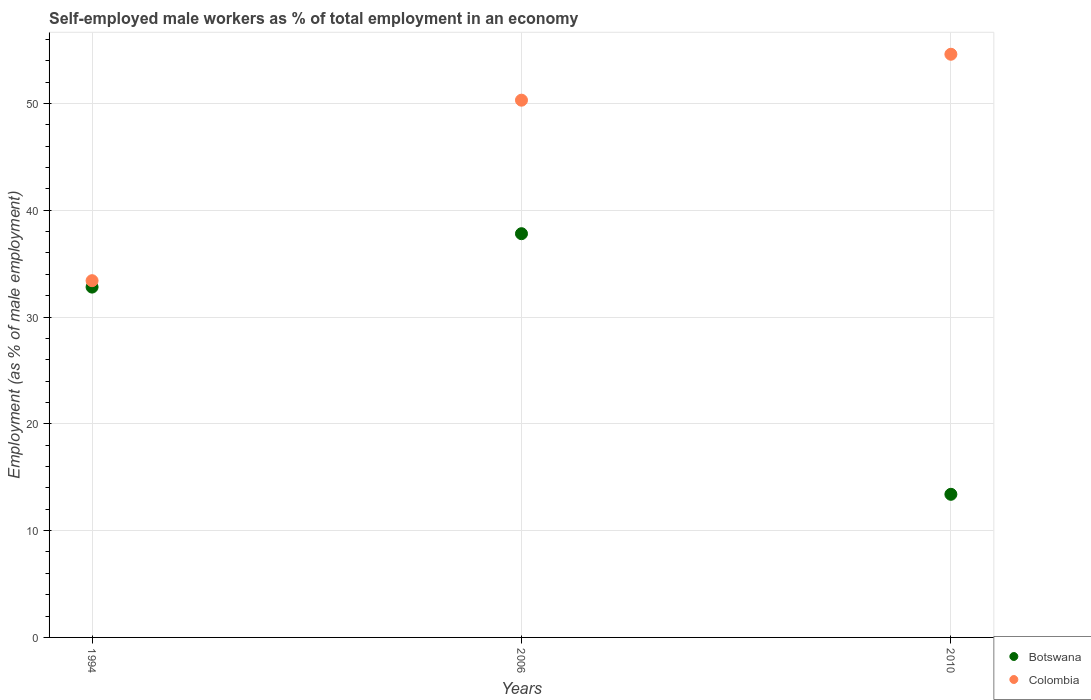How many different coloured dotlines are there?
Your answer should be compact. 2. Is the number of dotlines equal to the number of legend labels?
Give a very brief answer. Yes. What is the percentage of self-employed male workers in Colombia in 2006?
Ensure brevity in your answer.  50.3. Across all years, what is the maximum percentage of self-employed male workers in Botswana?
Provide a short and direct response. 37.8. Across all years, what is the minimum percentage of self-employed male workers in Colombia?
Provide a succinct answer. 33.4. In which year was the percentage of self-employed male workers in Botswana minimum?
Your response must be concise. 2010. What is the total percentage of self-employed male workers in Botswana in the graph?
Your response must be concise. 84. What is the difference between the percentage of self-employed male workers in Botswana in 1994 and that in 2006?
Ensure brevity in your answer.  -5. What is the difference between the percentage of self-employed male workers in Colombia in 2006 and the percentage of self-employed male workers in Botswana in 1994?
Keep it short and to the point. 17.5. What is the average percentage of self-employed male workers in Colombia per year?
Give a very brief answer. 46.1. In the year 1994, what is the difference between the percentage of self-employed male workers in Colombia and percentage of self-employed male workers in Botswana?
Your answer should be very brief. 0.6. In how many years, is the percentage of self-employed male workers in Colombia greater than 10 %?
Make the answer very short. 3. What is the ratio of the percentage of self-employed male workers in Botswana in 1994 to that in 2010?
Your answer should be very brief. 2.45. Is the difference between the percentage of self-employed male workers in Colombia in 2006 and 2010 greater than the difference between the percentage of self-employed male workers in Botswana in 2006 and 2010?
Your response must be concise. No. What is the difference between the highest and the second highest percentage of self-employed male workers in Colombia?
Offer a terse response. 4.3. What is the difference between the highest and the lowest percentage of self-employed male workers in Colombia?
Provide a short and direct response. 21.2. In how many years, is the percentage of self-employed male workers in Botswana greater than the average percentage of self-employed male workers in Botswana taken over all years?
Keep it short and to the point. 2. How many dotlines are there?
Your response must be concise. 2. How many years are there in the graph?
Give a very brief answer. 3. Are the values on the major ticks of Y-axis written in scientific E-notation?
Keep it short and to the point. No. Does the graph contain any zero values?
Provide a short and direct response. No. Does the graph contain grids?
Provide a short and direct response. Yes. Where does the legend appear in the graph?
Provide a short and direct response. Bottom right. How many legend labels are there?
Give a very brief answer. 2. How are the legend labels stacked?
Provide a short and direct response. Vertical. What is the title of the graph?
Offer a very short reply. Self-employed male workers as % of total employment in an economy. Does "Estonia" appear as one of the legend labels in the graph?
Your answer should be very brief. No. What is the label or title of the Y-axis?
Your answer should be compact. Employment (as % of male employment). What is the Employment (as % of male employment) in Botswana in 1994?
Ensure brevity in your answer.  32.8. What is the Employment (as % of male employment) in Colombia in 1994?
Your answer should be very brief. 33.4. What is the Employment (as % of male employment) of Botswana in 2006?
Give a very brief answer. 37.8. What is the Employment (as % of male employment) of Colombia in 2006?
Provide a succinct answer. 50.3. What is the Employment (as % of male employment) in Botswana in 2010?
Your response must be concise. 13.4. What is the Employment (as % of male employment) of Colombia in 2010?
Keep it short and to the point. 54.6. Across all years, what is the maximum Employment (as % of male employment) in Botswana?
Give a very brief answer. 37.8. Across all years, what is the maximum Employment (as % of male employment) of Colombia?
Your answer should be compact. 54.6. Across all years, what is the minimum Employment (as % of male employment) of Botswana?
Your response must be concise. 13.4. Across all years, what is the minimum Employment (as % of male employment) in Colombia?
Provide a short and direct response. 33.4. What is the total Employment (as % of male employment) in Colombia in the graph?
Keep it short and to the point. 138.3. What is the difference between the Employment (as % of male employment) of Colombia in 1994 and that in 2006?
Your answer should be very brief. -16.9. What is the difference between the Employment (as % of male employment) of Colombia in 1994 and that in 2010?
Your answer should be compact. -21.2. What is the difference between the Employment (as % of male employment) in Botswana in 2006 and that in 2010?
Give a very brief answer. 24.4. What is the difference between the Employment (as % of male employment) of Botswana in 1994 and the Employment (as % of male employment) of Colombia in 2006?
Ensure brevity in your answer.  -17.5. What is the difference between the Employment (as % of male employment) of Botswana in 1994 and the Employment (as % of male employment) of Colombia in 2010?
Provide a short and direct response. -21.8. What is the difference between the Employment (as % of male employment) of Botswana in 2006 and the Employment (as % of male employment) of Colombia in 2010?
Keep it short and to the point. -16.8. What is the average Employment (as % of male employment) of Colombia per year?
Ensure brevity in your answer.  46.1. In the year 2006, what is the difference between the Employment (as % of male employment) of Botswana and Employment (as % of male employment) of Colombia?
Ensure brevity in your answer.  -12.5. In the year 2010, what is the difference between the Employment (as % of male employment) of Botswana and Employment (as % of male employment) of Colombia?
Provide a short and direct response. -41.2. What is the ratio of the Employment (as % of male employment) of Botswana in 1994 to that in 2006?
Give a very brief answer. 0.87. What is the ratio of the Employment (as % of male employment) of Colombia in 1994 to that in 2006?
Provide a succinct answer. 0.66. What is the ratio of the Employment (as % of male employment) of Botswana in 1994 to that in 2010?
Make the answer very short. 2.45. What is the ratio of the Employment (as % of male employment) in Colombia in 1994 to that in 2010?
Offer a terse response. 0.61. What is the ratio of the Employment (as % of male employment) of Botswana in 2006 to that in 2010?
Ensure brevity in your answer.  2.82. What is the ratio of the Employment (as % of male employment) in Colombia in 2006 to that in 2010?
Offer a very short reply. 0.92. What is the difference between the highest and the second highest Employment (as % of male employment) in Colombia?
Give a very brief answer. 4.3. What is the difference between the highest and the lowest Employment (as % of male employment) of Botswana?
Offer a terse response. 24.4. What is the difference between the highest and the lowest Employment (as % of male employment) of Colombia?
Give a very brief answer. 21.2. 